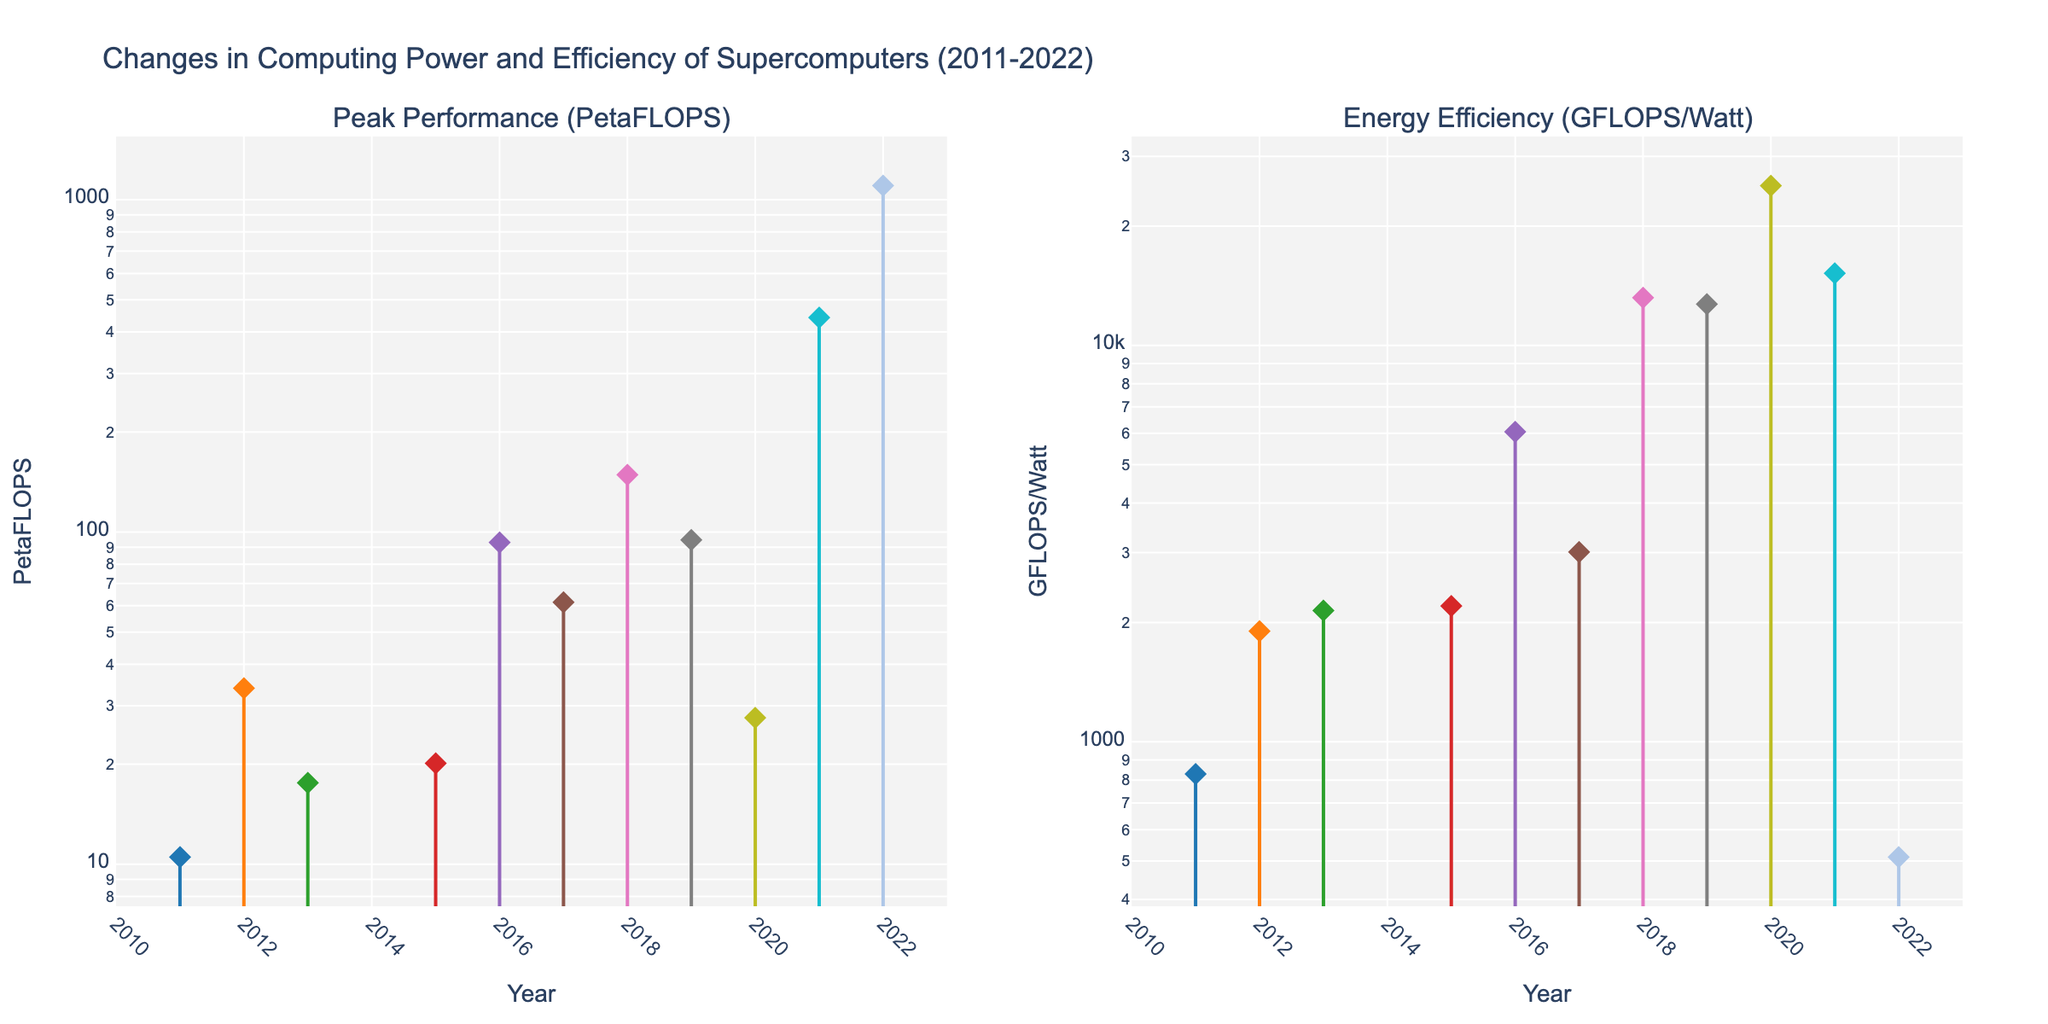What are the titles of the two subplots? The figure has two subplots with different titles. The left subplot is titled "Peak Performance (PetaFLOPS)" and the right subplot is titled "Energy Efficiency (GFLOPS/Watt)."
Answer: Peak Performance (PetaFLOPS), Energy Efficiency (GFLOPS/Watt) Which supercomputer shows the highest Peak Performance in 2022? Observing the data points and lines on the left subplot, Frontier is the supercomputer with the highest Peak Performance in 2022, reaching 1102 PetaFLOPS.
Answer: Frontier In which year did the Fujitsu K supercomputer have its performance recorded? Look at the x-axis for "Year" and trace the line corresponding to Fujitsu K. The marker indicating performance appears in 2011.
Answer: 2011 What is the increase in Peak Performance from 2011 to 2022? The Peak Performance in 2011 by Fujitsu K was 10.51 PetaFLOPS, and the performance in 2022 by Frontier was 1102 PetaFLOPS. The increase is calculated as 1102 - 10.51 = 1091.49 PetaFLOPS.
Answer: 1091.49 PetaFLOPS Which year witnessed the largest improvement in Energy Efficiency? By tracing the right subplot for significant increases, it's clear that between 2019 (Sierra at 12710.9 GFLOPS/Watt) and 2020 (Selene at 25293.5 GFLOPS/Watt), there is the largest jump in energy efficiency.
Answer: 2020 Compare the Peak Performance of the Summit (2018) and Sunway TaihuLight (2016) supercomputers. Which one is higher and by how much? Summit in 2018 has 148.6 PetaFLOPS, while Sunway TaihuLight in 2016 has 93.01 PetaFLOPS. The difference is 148.6 - 93.01 = 55.59 PetaFLOPS, with Summit being higher.
Answer: Summit by 55.59 PetaFLOPS What trend can be observed in the Energy Efficiency of supercomputers from 2011 to 2022? The right subplot shows a general increase in energy efficiency over the past decade, with some fluctuations. Most supercomputers improved in GFLOPS/Watt significantly over the years, despite some dips.
Answer: General increase What is the average Peak Performance of the supercomputers listed between 2015 and 2022? Sum the Peak Performance values: (20.13 + 93.01 + 61.44 + 148.6 + 94.64 + 27.6 + 442.01 + 1102) = 1989.43 PetaFLOPS. There are 8 data points, so the average is 1989.43 / 8 = 248.68 PetaFLOPS.
Answer: 248.68 PetaFLOPS Which supercomputer has the highest Energy Efficiency in the entire dataset, and what is its value? From the right subplot, Selene in 2020 has the highest energy efficiency recorded at 25293.5 GFLOPS/Watt.
Answer: Selene, 25293.5 GFLOPS/Watt 